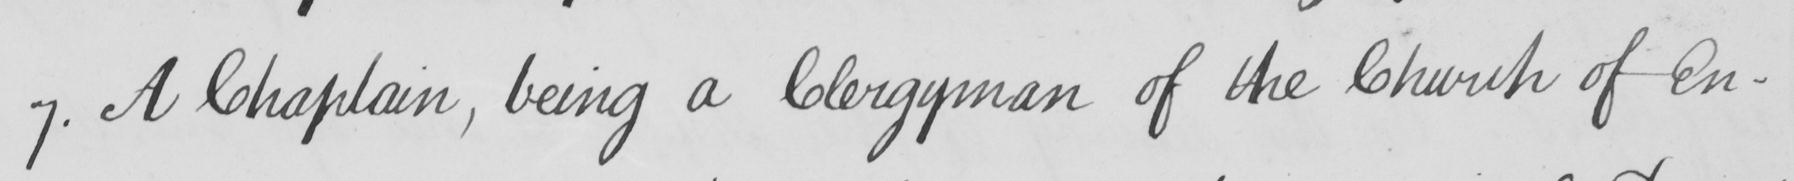Can you tell me what this handwritten text says? 7 . A Chaplain , being a Clergyman of the Church of En- 